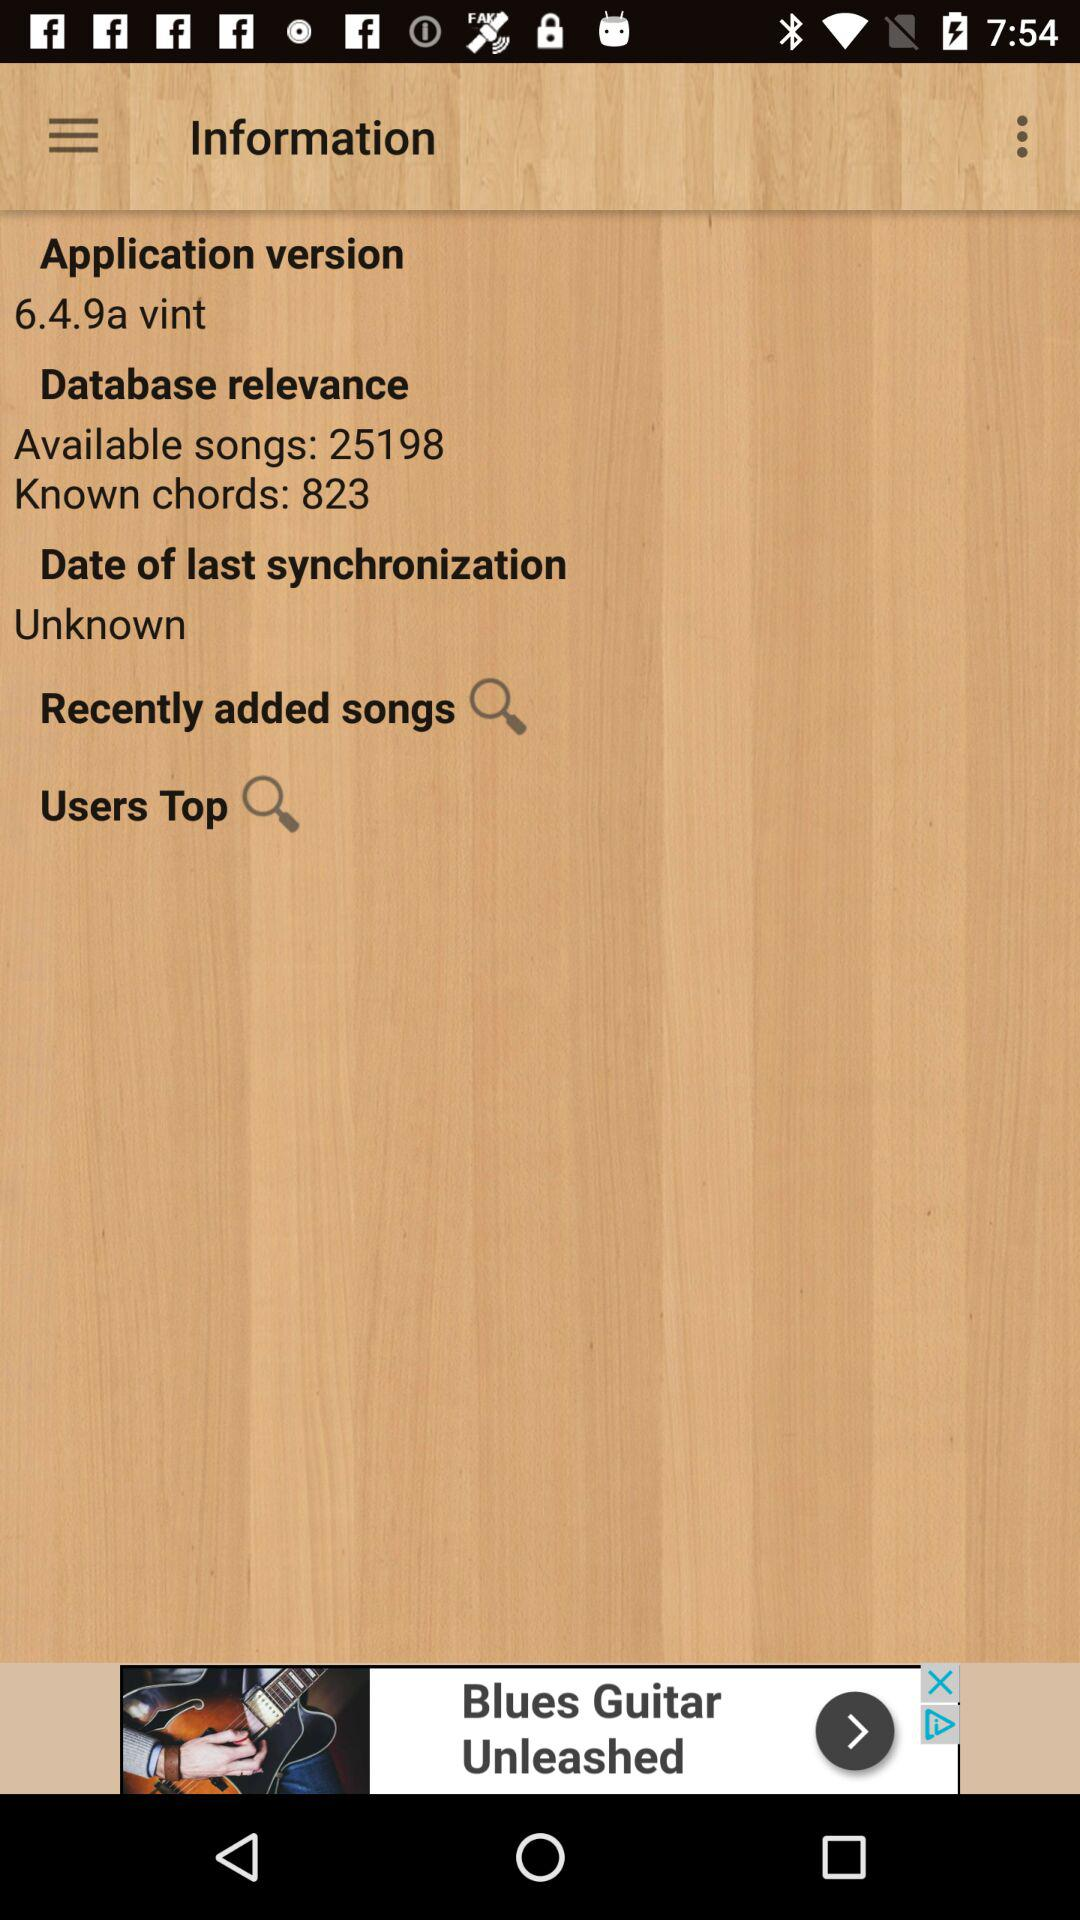How many more songs are available than known chords?
Answer the question using a single word or phrase. 24375 